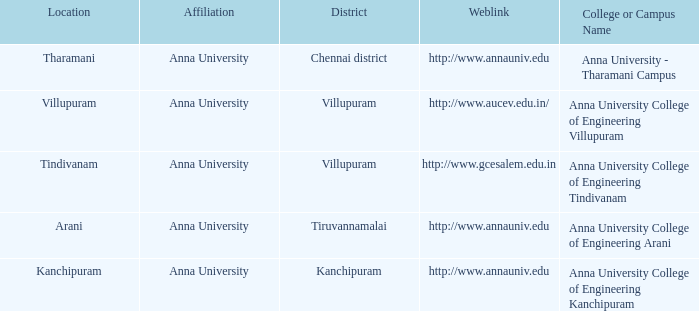What District has a Location of villupuram? Villupuram. 